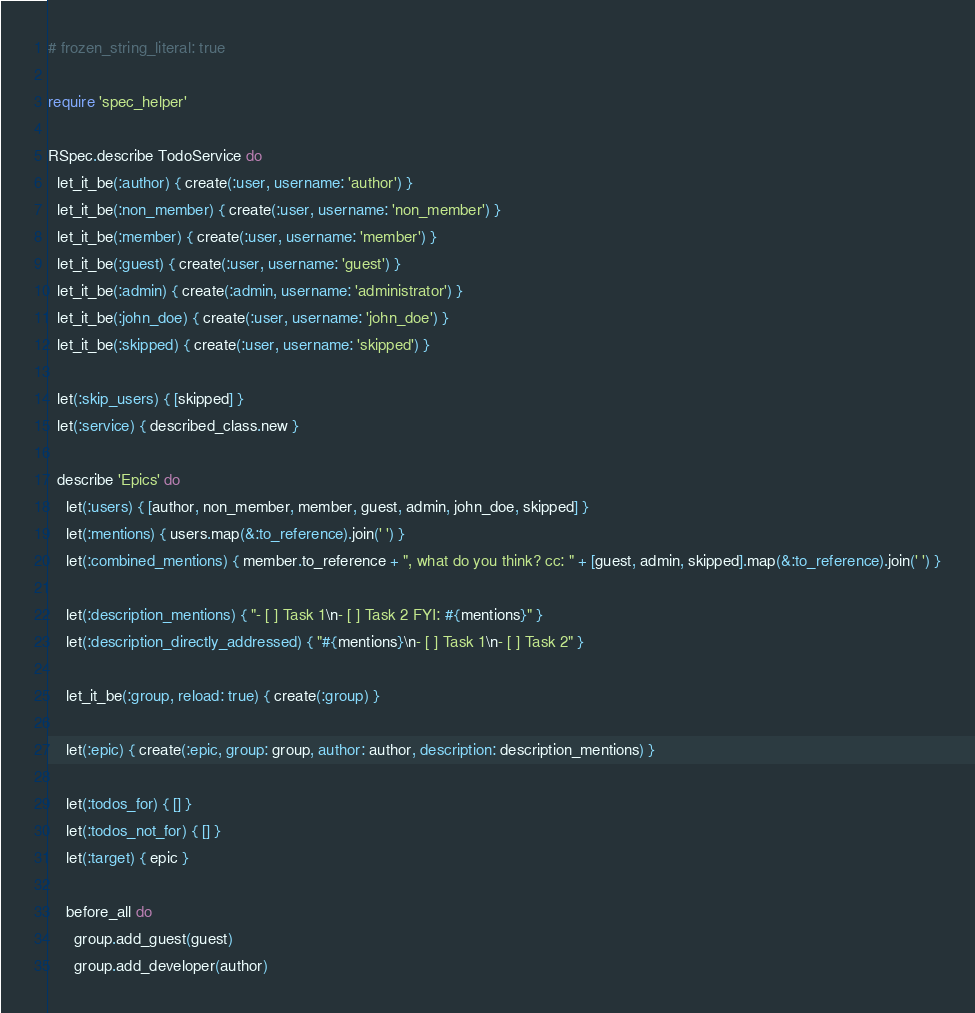Convert code to text. <code><loc_0><loc_0><loc_500><loc_500><_Ruby_># frozen_string_literal: true

require 'spec_helper'

RSpec.describe TodoService do
  let_it_be(:author) { create(:user, username: 'author') }
  let_it_be(:non_member) { create(:user, username: 'non_member') }
  let_it_be(:member) { create(:user, username: 'member') }
  let_it_be(:guest) { create(:user, username: 'guest') }
  let_it_be(:admin) { create(:admin, username: 'administrator') }
  let_it_be(:john_doe) { create(:user, username: 'john_doe') }
  let_it_be(:skipped) { create(:user, username: 'skipped') }

  let(:skip_users) { [skipped] }
  let(:service) { described_class.new }

  describe 'Epics' do
    let(:users) { [author, non_member, member, guest, admin, john_doe, skipped] }
    let(:mentions) { users.map(&:to_reference).join(' ') }
    let(:combined_mentions) { member.to_reference + ", what do you think? cc: " + [guest, admin, skipped].map(&:to_reference).join(' ') }

    let(:description_mentions) { "- [ ] Task 1\n- [ ] Task 2 FYI: #{mentions}" }
    let(:description_directly_addressed) { "#{mentions}\n- [ ] Task 1\n- [ ] Task 2" }

    let_it_be(:group, reload: true) { create(:group) }

    let(:epic) { create(:epic, group: group, author: author, description: description_mentions) }

    let(:todos_for) { [] }
    let(:todos_not_for) { [] }
    let(:target) { epic }

    before_all do
      group.add_guest(guest)
      group.add_developer(author)</code> 